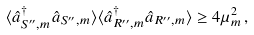<formula> <loc_0><loc_0><loc_500><loc_500>\langle \hat { a } _ { S ^ { \prime \prime } , m } ^ { \dagger } \hat { a } _ { S ^ { \prime \prime } , m } \rangle \langle \hat { a } _ { R ^ { \prime \prime } , m } ^ { \dagger } \hat { a } _ { R ^ { \prime \prime } , m } \rangle \geq 4 \mu _ { m } ^ { 2 } \, ,</formula> 